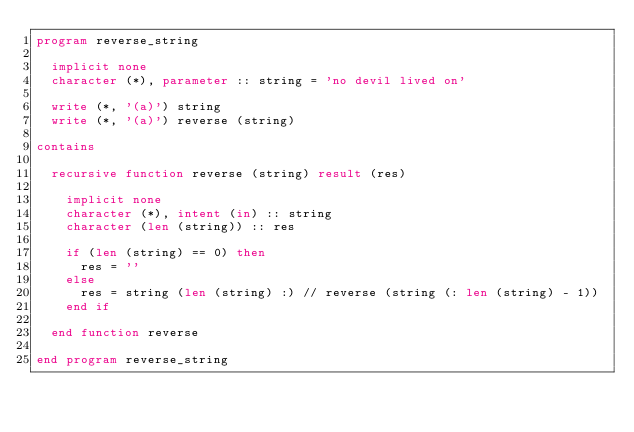Convert code to text. <code><loc_0><loc_0><loc_500><loc_500><_FORTRAN_>program reverse_string

  implicit none
  character (*), parameter :: string = 'no devil lived on'

  write (*, '(a)') string
  write (*, '(a)') reverse (string)

contains

  recursive function reverse (string) result (res)

    implicit none
    character (*), intent (in) :: string
    character (len (string)) :: res

    if (len (string) == 0) then
      res = ''
    else
      res = string (len (string) :) // reverse (string (: len (string) - 1))
    end if

  end function reverse

end program reverse_string
</code> 